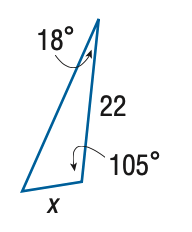Answer the mathemtical geometry problem and directly provide the correct option letter.
Question: Find x. Round side measure to the nearest tenth.
Choices: A: 7.0 B: 8.1 C: 59.7 D: 68.8 B 